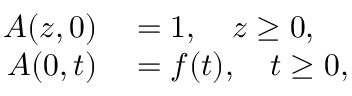<formula> <loc_0><loc_0><loc_500><loc_500>\begin{array} { r l } { A ( z , 0 ) } & = 1 , \quad z \geq 0 , } \\ { A ( 0 , t ) } & = f ( t ) , \quad t \geq 0 , } \end{array}</formula> 